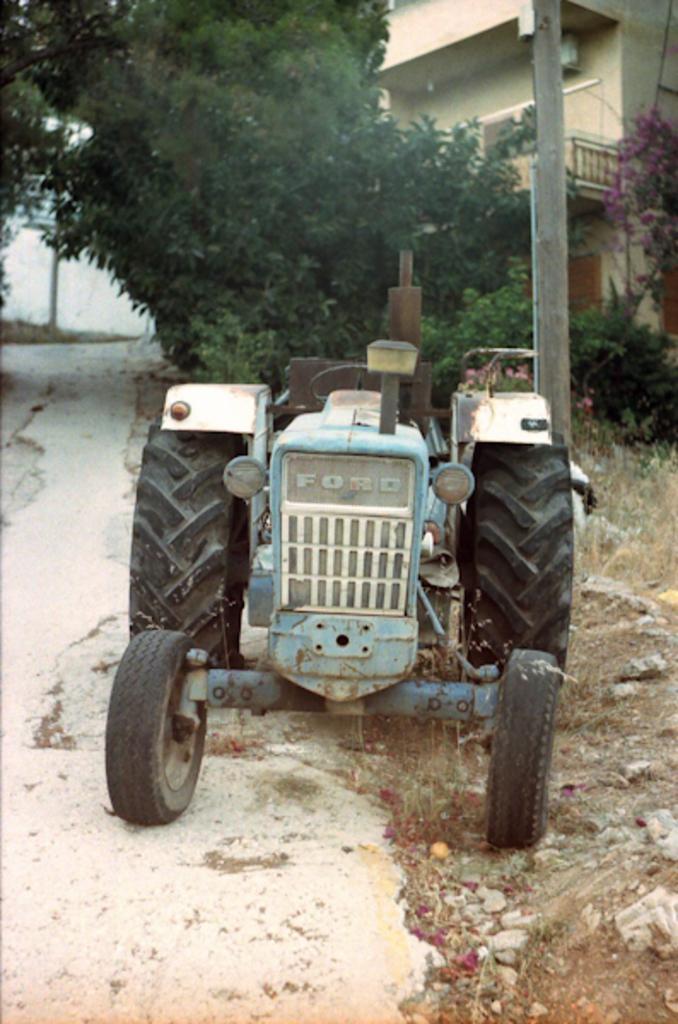Could you give a brief overview of what you see in this image? In the image in the center we can see one tractor. In the background we can see trees,plants,grass,flowers,stones,building,wall,fence,pole and road. 